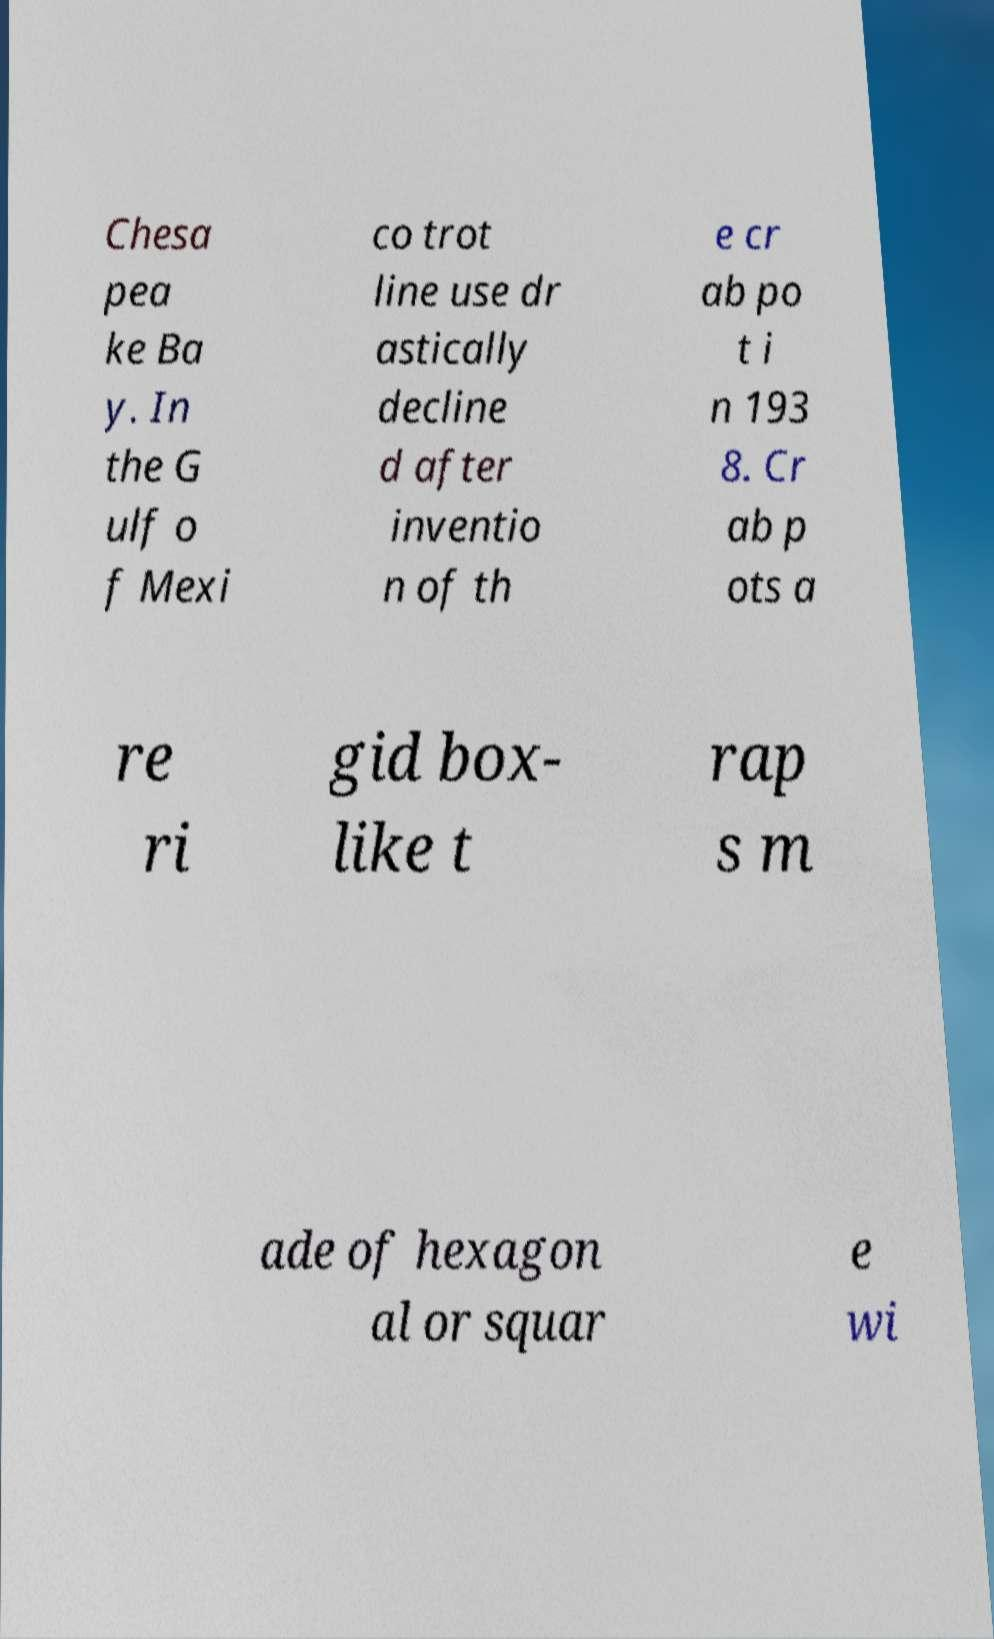I need the written content from this picture converted into text. Can you do that? Chesa pea ke Ba y. In the G ulf o f Mexi co trot line use dr astically decline d after inventio n of th e cr ab po t i n 193 8. Cr ab p ots a re ri gid box- like t rap s m ade of hexagon al or squar e wi 